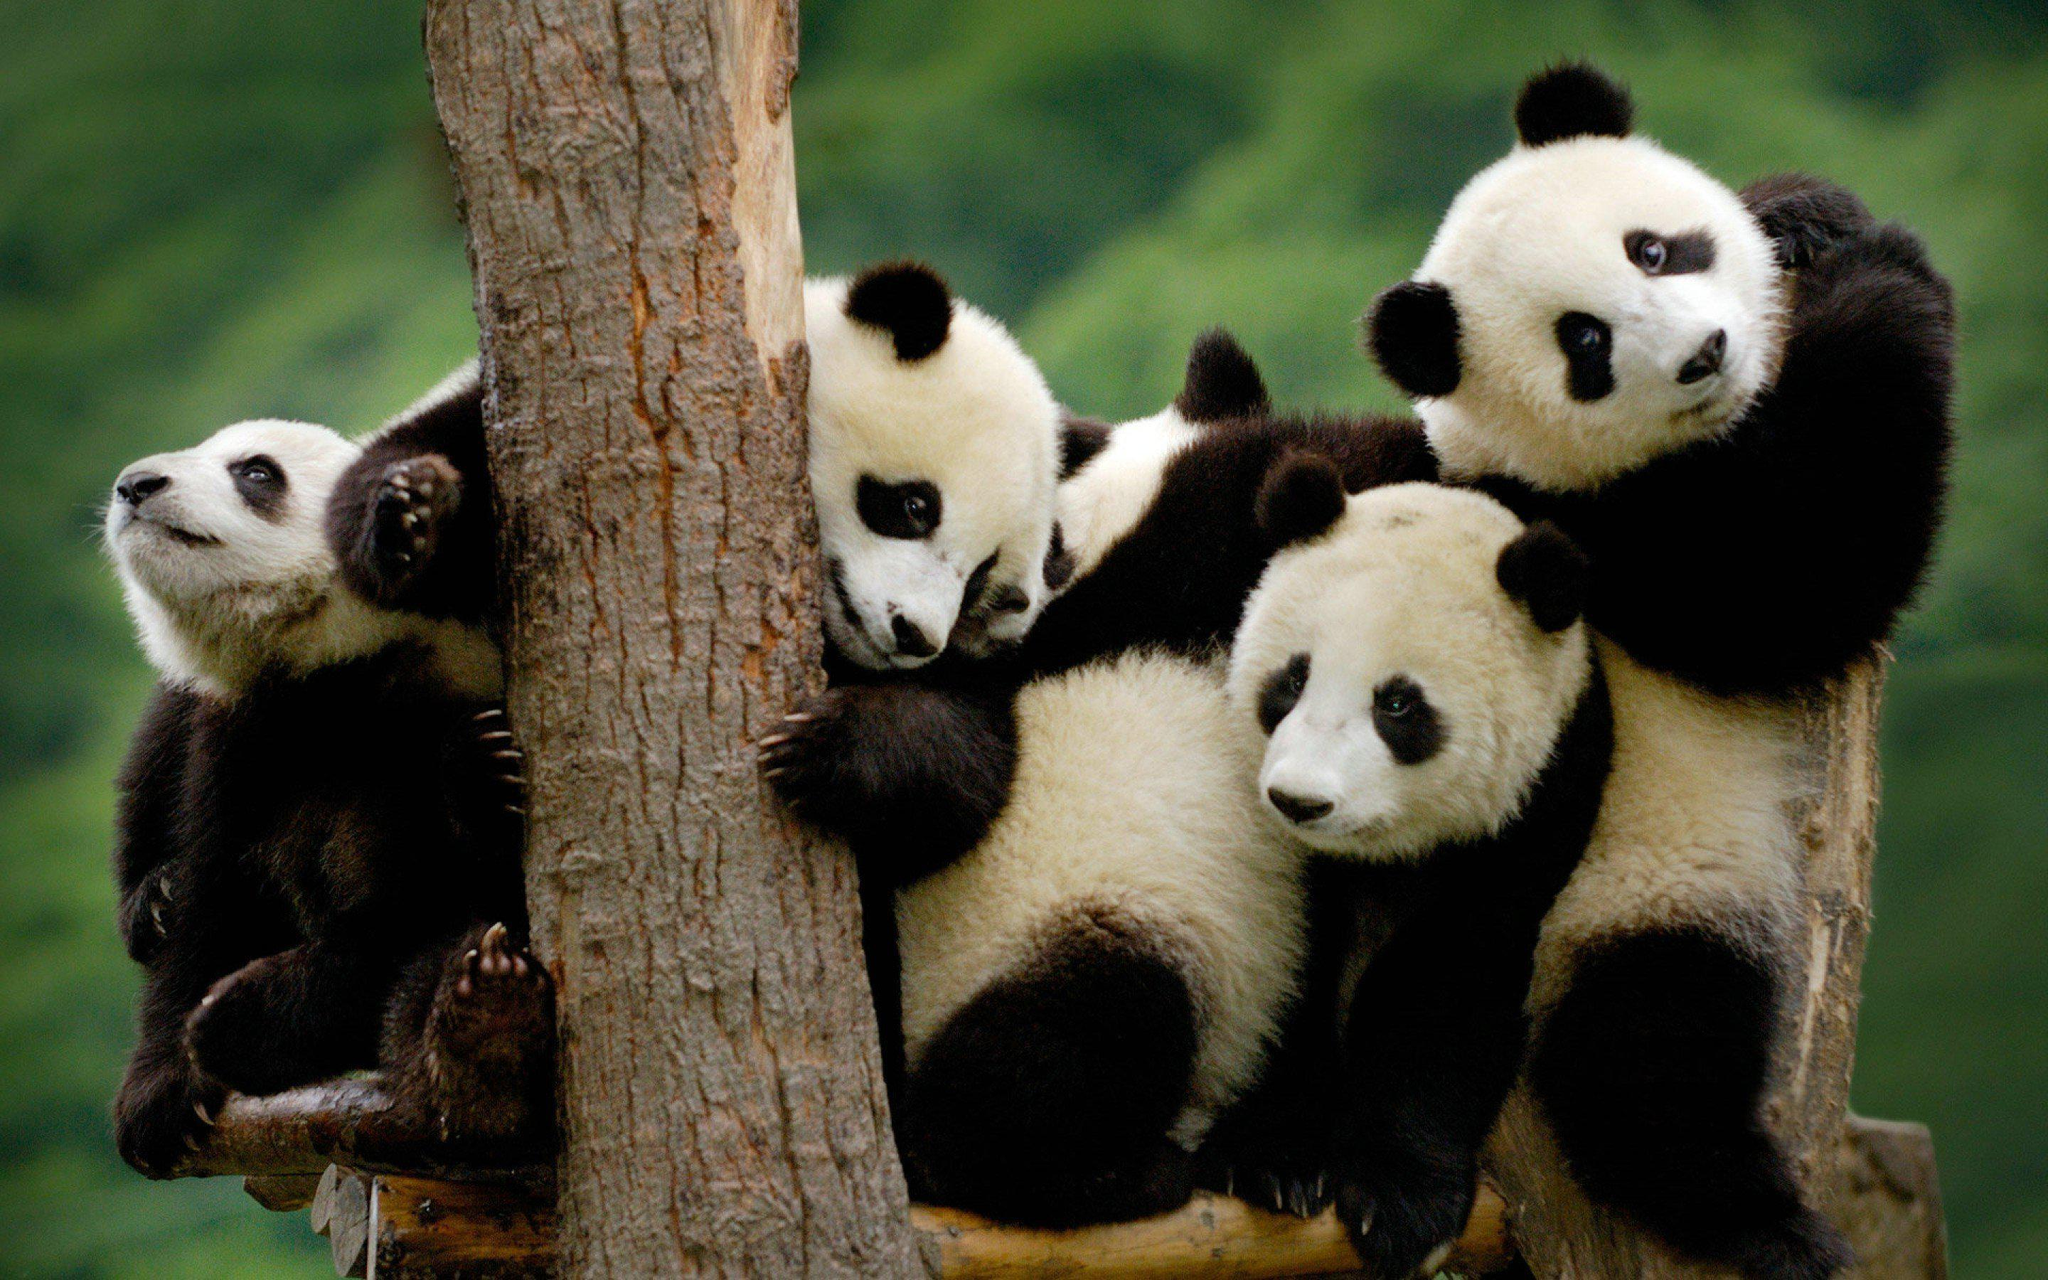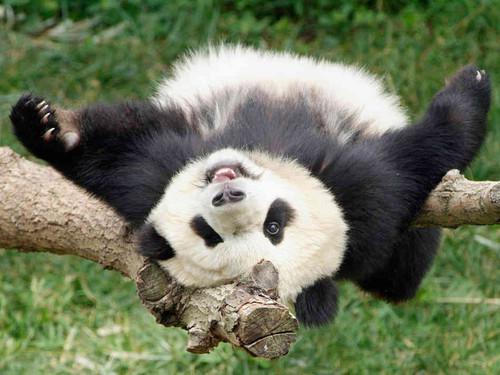The first image is the image on the left, the second image is the image on the right. Given the left and right images, does the statement "An image shows one panda playing with a toy, with its front paws grasping the object." hold true? Answer yes or no. No. The first image is the image on the left, the second image is the image on the right. Considering the images on both sides, is "One of the images show a single panda holding an object." valid? Answer yes or no. No. 